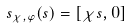<formula> <loc_0><loc_0><loc_500><loc_500>\ s _ { \chi , \varphi } ( s ) = [ \chi s , 0 ]</formula> 